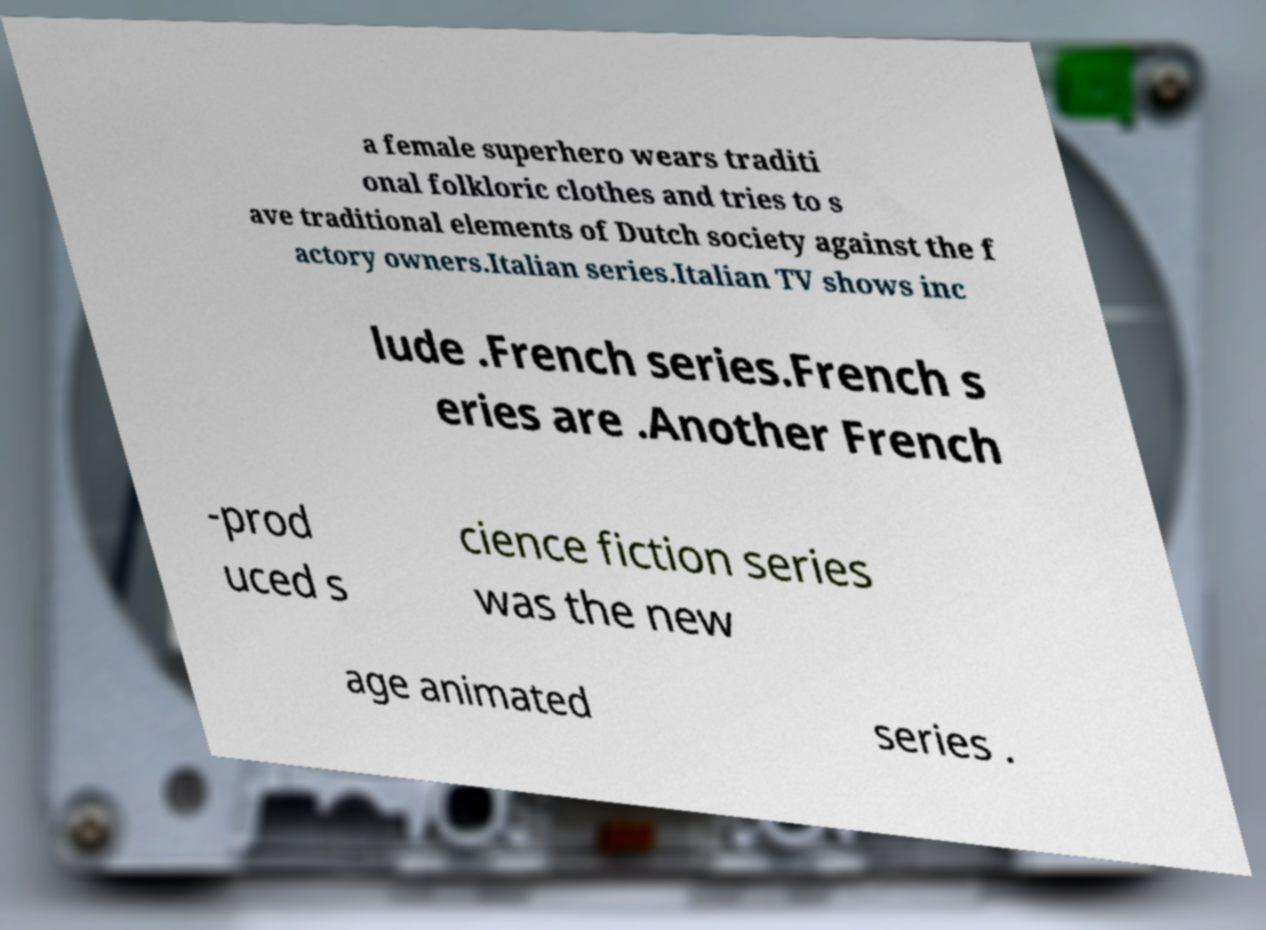Could you assist in decoding the text presented in this image and type it out clearly? a female superhero wears traditi onal folkloric clothes and tries to s ave traditional elements of Dutch society against the f actory owners.Italian series.Italian TV shows inc lude .French series.French s eries are .Another French -prod uced s cience fiction series was the new age animated series . 